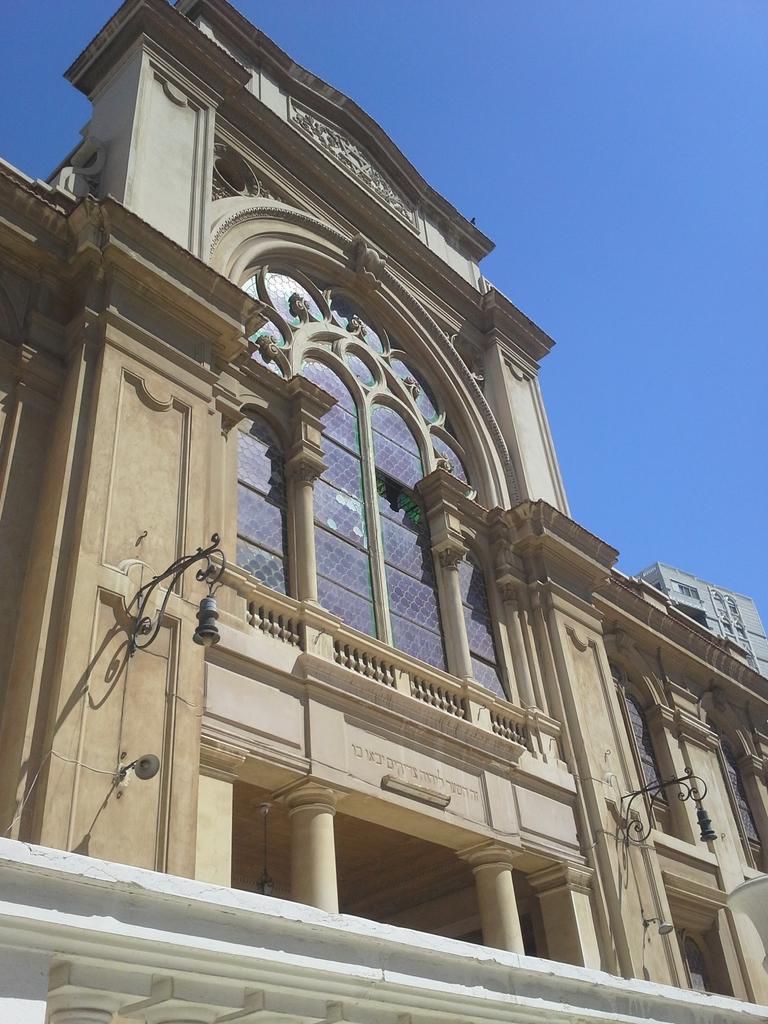What type of structure is visible in the image? There is a building in the image. Where is the light located in the image? The light is on the right side of the image. What is visible at the top of the image? The sky is visible at the top of the image. What type of trousers is the building wearing in the image? Buildings do not wear trousers, as they are inanimate objects. 